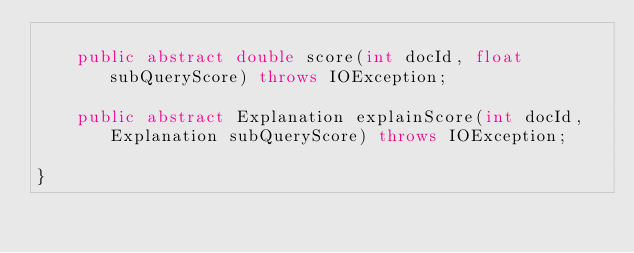<code> <loc_0><loc_0><loc_500><loc_500><_Java_>
    public abstract double score(int docId, float subQueryScore) throws IOException;

    public abstract Explanation explainScore(int docId, Explanation subQueryScore) throws IOException;

}
</code> 